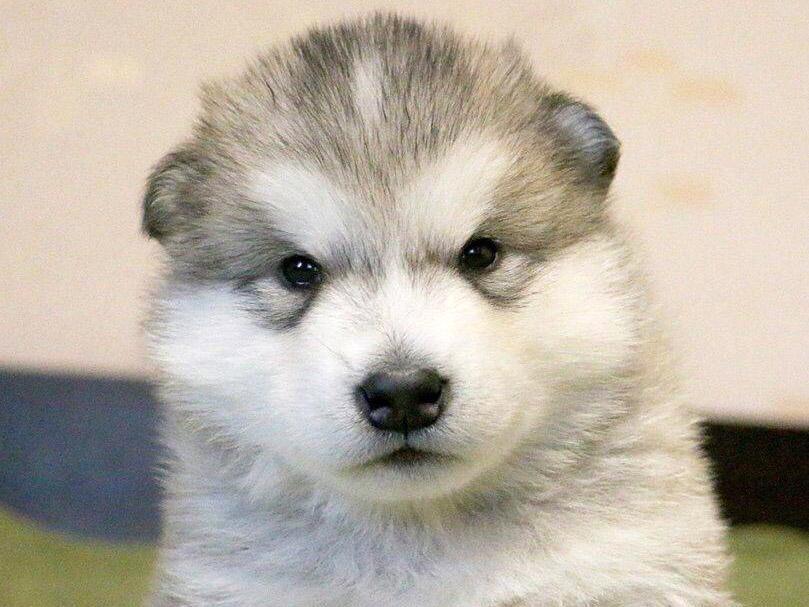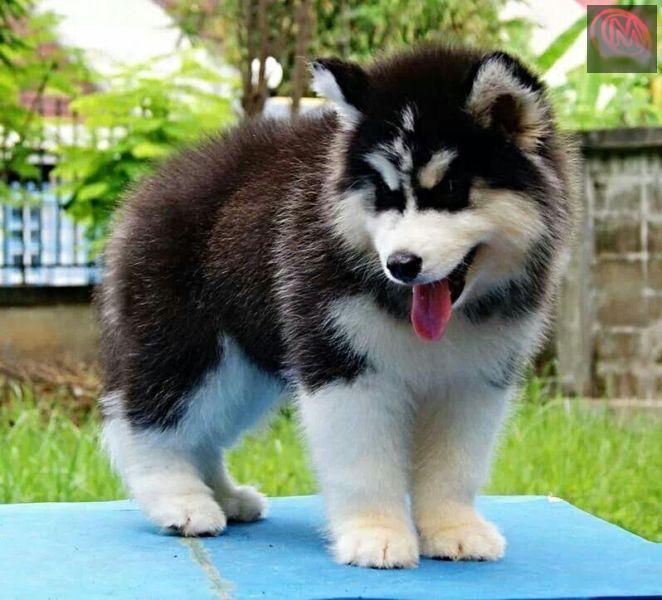The first image is the image on the left, the second image is the image on the right. For the images displayed, is the sentence "There are exactly two dogs." factually correct? Answer yes or no. Yes. 